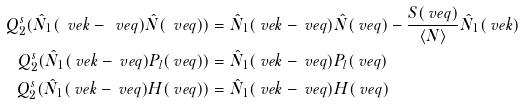Convert formula to latex. <formula><loc_0><loc_0><loc_500><loc_500>Q _ { 2 } ^ { s } ( \hat { N } _ { 1 } ( \ v e k - \ v e q ) \hat { N } ( \ v e q ) ) & = \hat { N } _ { 1 } ( \ v e k - \ v e q ) \hat { N } ( \ v e q ) - \frac { S ( \ v e q ) } { \langle N \rangle } \hat { N } _ { 1 } ( \ v e k ) \\ Q _ { 2 } ^ { s } ( \hat { N } _ { 1 } ( \ v e k - \ v e q ) P _ { l } ( \ v e q ) ) & = \hat { N } _ { 1 } ( \ v e k - \ v e q ) P _ { l } ( \ v e q ) \\ Q _ { 2 } ^ { s } ( \hat { N } _ { 1 } ( \ v e k - \ v e q ) H ( \ v e q ) ) & = \hat { N } _ { 1 } ( \ v e k - \ v e q ) H ( \ v e q )</formula> 